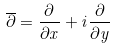Convert formula to latex. <formula><loc_0><loc_0><loc_500><loc_500>\overline { \partial } = \frac { \partial } { \partial x } + i \frac { \partial } { \partial y }</formula> 